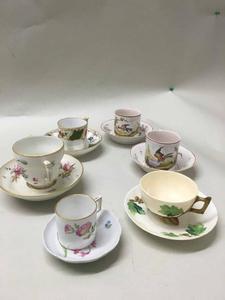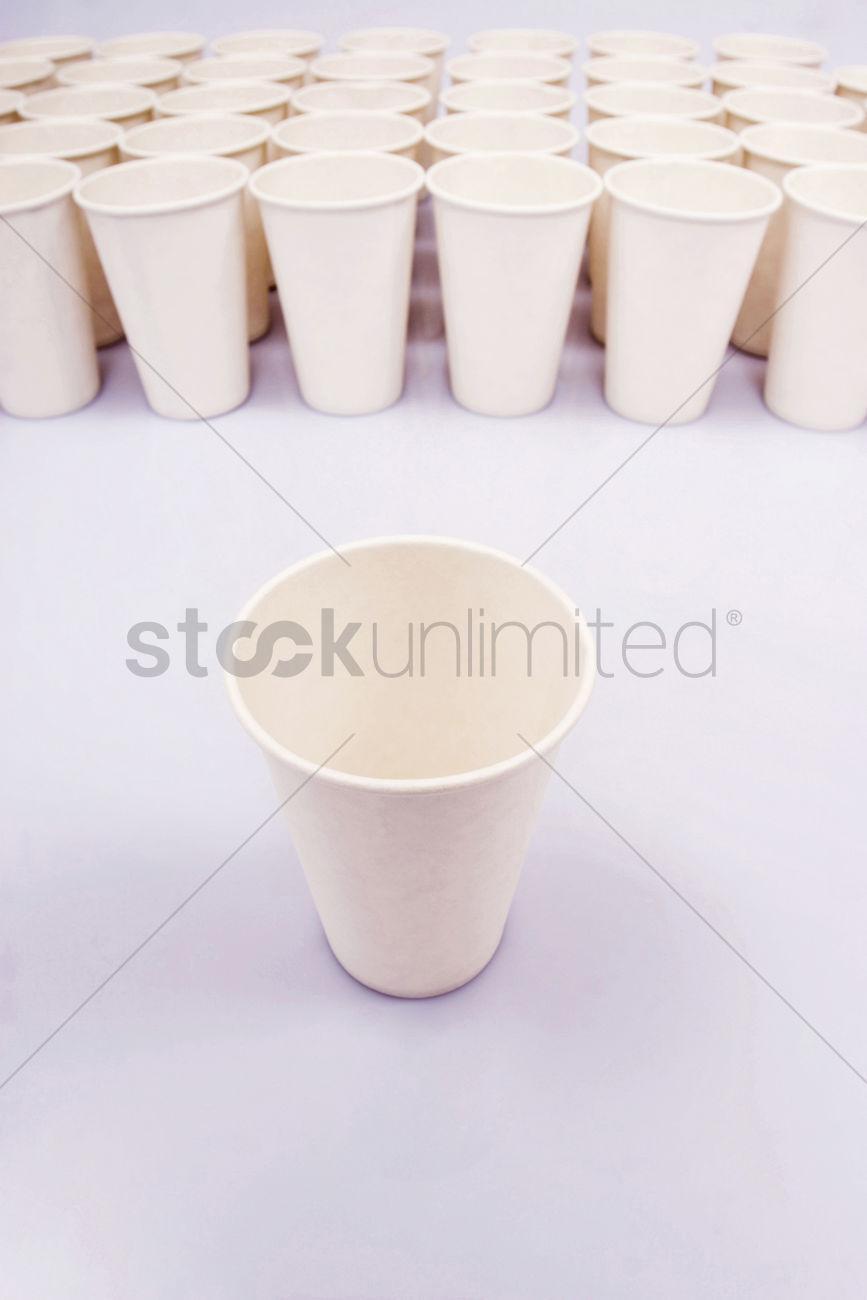The first image is the image on the left, the second image is the image on the right. Given the left and right images, does the statement "At least one of the cups contains a beverage." hold true? Answer yes or no. No. 